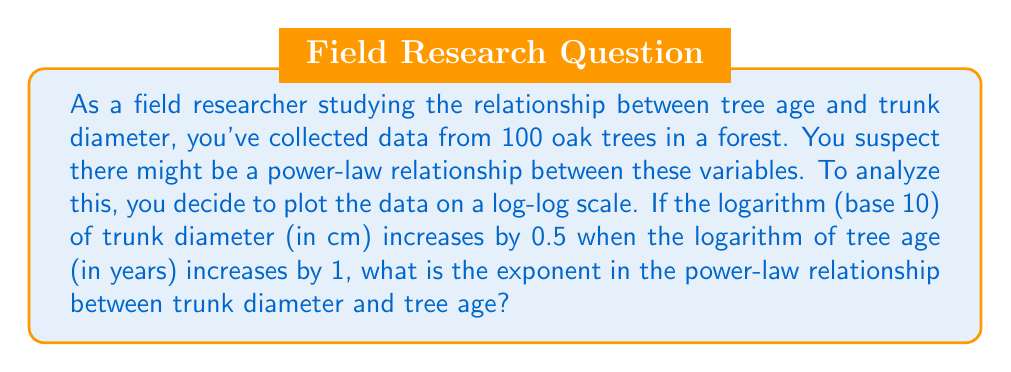Could you help me with this problem? Let's approach this step-by-step:

1) In a power-law relationship, we have:
   $y = ax^b$
   where $y$ is the trunk diameter, $x$ is the tree age, $a$ is a constant, and $b$ is the exponent we're looking for.

2) Taking the logarithm (base 10) of both sides:
   $\log y = \log(ax^b) = \log a + b \log x$

3) This is a linear equation in log-log space, with slope $b$.

4) We're told that when $\log x$ increases by 1, $\log y$ increases by 0.5.
   This means the slope of the line in log-log space is 0.5.

5) Therefore, $b = 0.5$

6) To verify, let's consider two points $(x_1, y_1)$ and $(x_2, y_2)$ where:
   $\log x_2 - \log x_1 = 1$
   $\log y_2 - \log y_1 = 0.5$

7) The slope between these points is:
   $b = \frac{\log y_2 - \log y_1}{\log x_2 - \log x_1} = \frac{0.5}{1} = 0.5$

Thus, the exponent in the power-law relationship is 0.5.
Answer: 0.5 